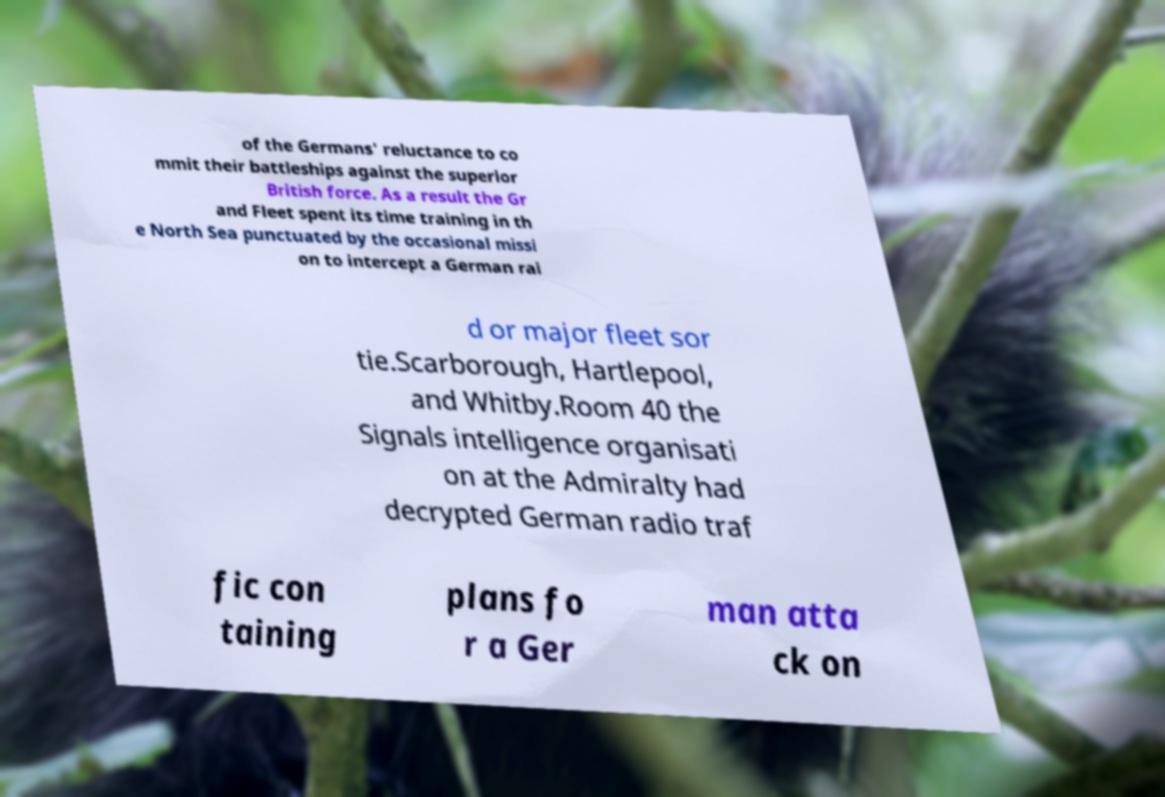What messages or text are displayed in this image? I need them in a readable, typed format. of the Germans' reluctance to co mmit their battleships against the superior British force. As a result the Gr and Fleet spent its time training in th e North Sea punctuated by the occasional missi on to intercept a German rai d or major fleet sor tie.Scarborough, Hartlepool, and Whitby.Room 40 the Signals intelligence organisati on at the Admiralty had decrypted German radio traf fic con taining plans fo r a Ger man atta ck on 